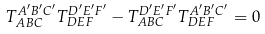<formula> <loc_0><loc_0><loc_500><loc_500>T _ { A B C } ^ { A ^ { \prime } B ^ { \prime } C ^ { \prime } } T _ { D E F } ^ { D ^ { \prime } E ^ { \prime } F ^ { \prime } } - T _ { A B C } ^ { D ^ { \prime } E ^ { \prime } F ^ { \prime } } T _ { D E F } ^ { A ^ { \prime } B ^ { \prime } C ^ { \prime } } = 0</formula> 